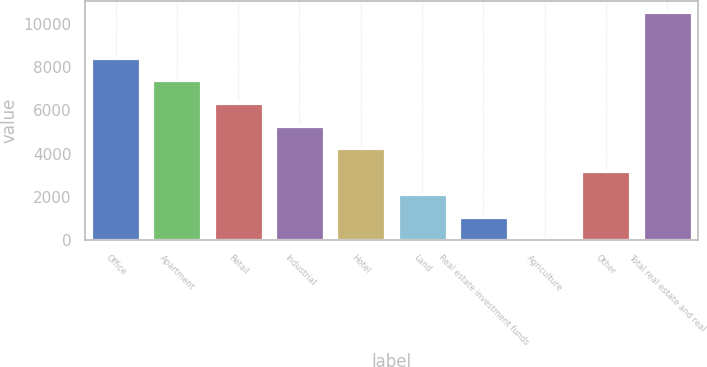Convert chart. <chart><loc_0><loc_0><loc_500><loc_500><bar_chart><fcel>Office<fcel>Apartment<fcel>Retail<fcel>Industrial<fcel>Hotel<fcel>Land<fcel>Real estate investment funds<fcel>Agriculture<fcel>Other<fcel>Total real estate and real<nl><fcel>8427.4<fcel>7378.6<fcel>6329.8<fcel>5281<fcel>4232.2<fcel>2134.6<fcel>1085.8<fcel>37<fcel>3183.4<fcel>10525<nl></chart> 